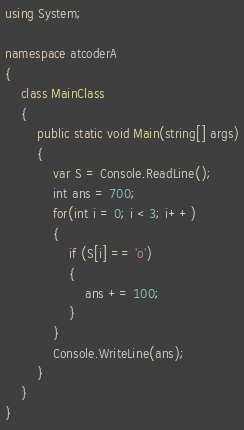Convert code to text. <code><loc_0><loc_0><loc_500><loc_500><_C#_>using System;

namespace atcoderA
{
    class MainClass
    {
        public static void Main(string[] args)
        {
            var S = Console.ReadLine();
            int ans = 700;
            for(int i = 0; i < 3; i++)
            {
                if (S[i] == 'o')
                {
                    ans += 100;
                }
            }
            Console.WriteLine(ans);
        }
    }
}</code> 